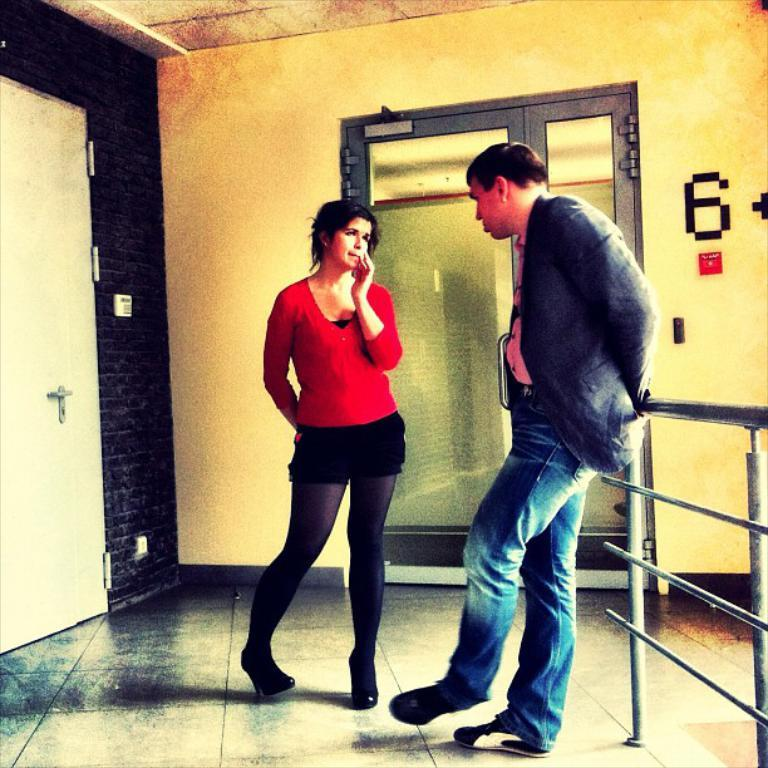How many people are in the image? There are two people standing in the image. What are the people wearing? The people are wearing different color dresses. What architectural features can be seen in the image? There are doors, a wall, and an iron railing visible in the image. Can you tell me how many knives are being used by the people in the image? There is no knife present in the image. What type of behavior is exhibited by the kitty in the image? There is no kitty present in the image. 